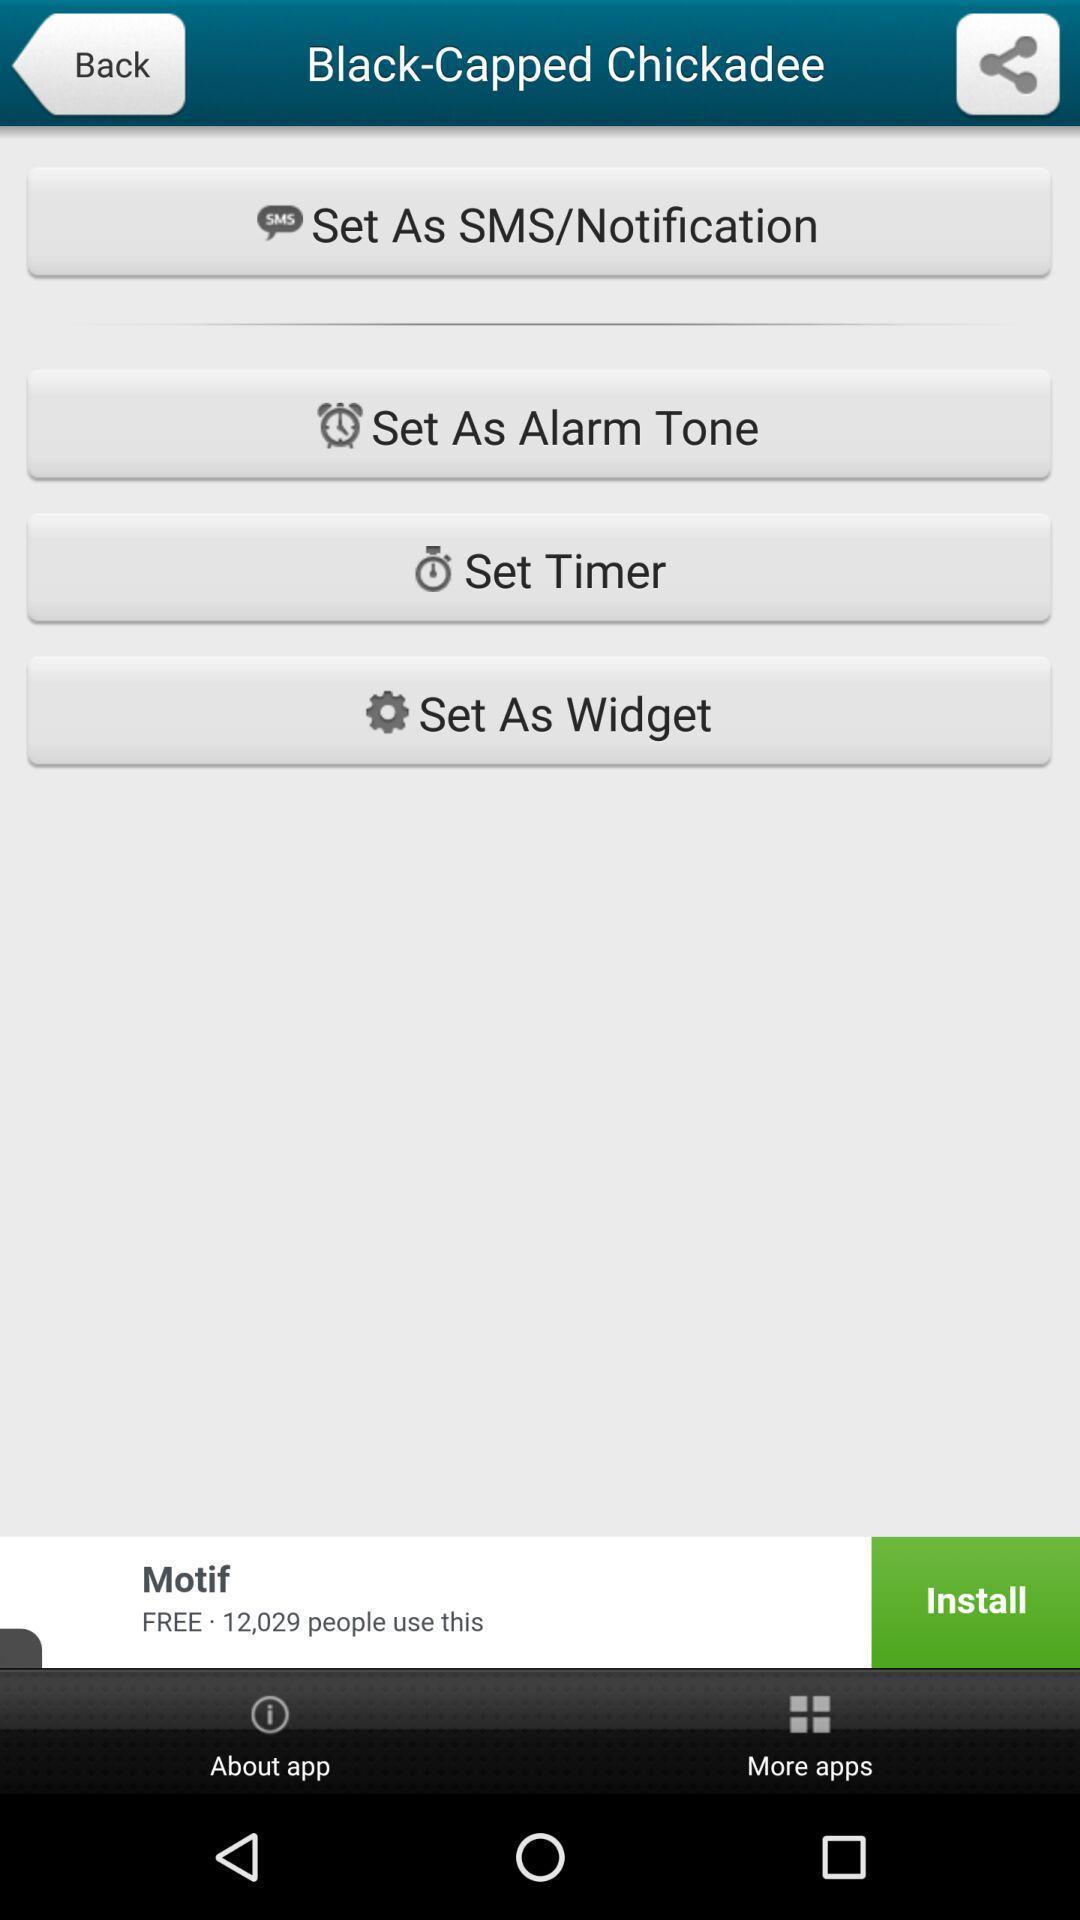Tell me about the visual elements in this screen capture. Page showing various options to set for ringtone app. 